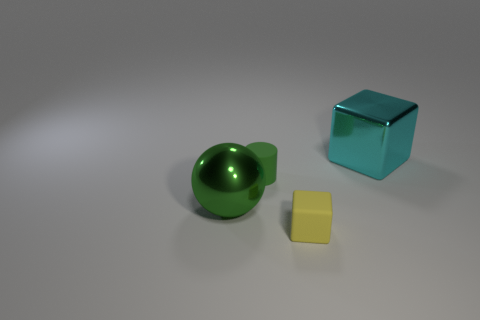How many other green rubber cylinders are the same size as the green matte cylinder?
Your answer should be compact. 0. Is the number of big metal spheres that are on the left side of the cyan block the same as the number of green rubber objects?
Keep it short and to the point. Yes. What number of big metallic things are both behind the ball and in front of the cyan cube?
Keep it short and to the point. 0. The green sphere that is made of the same material as the big cyan thing is what size?
Make the answer very short. Large. What number of other big things are the same shape as the yellow object?
Provide a short and direct response. 1. Is the number of cyan blocks that are to the right of the yellow thing greater than the number of big blue rubber spheres?
Provide a succinct answer. Yes. What shape is the object that is both in front of the matte cylinder and to the left of the small yellow block?
Your answer should be very brief. Sphere. Do the shiny block and the green matte thing have the same size?
Give a very brief answer. No. There is a small rubber block; how many tiny matte things are left of it?
Offer a very short reply. 1. Is the number of big cyan metal cubes in front of the cyan metal object the same as the number of green balls on the left side of the yellow object?
Offer a very short reply. No. 